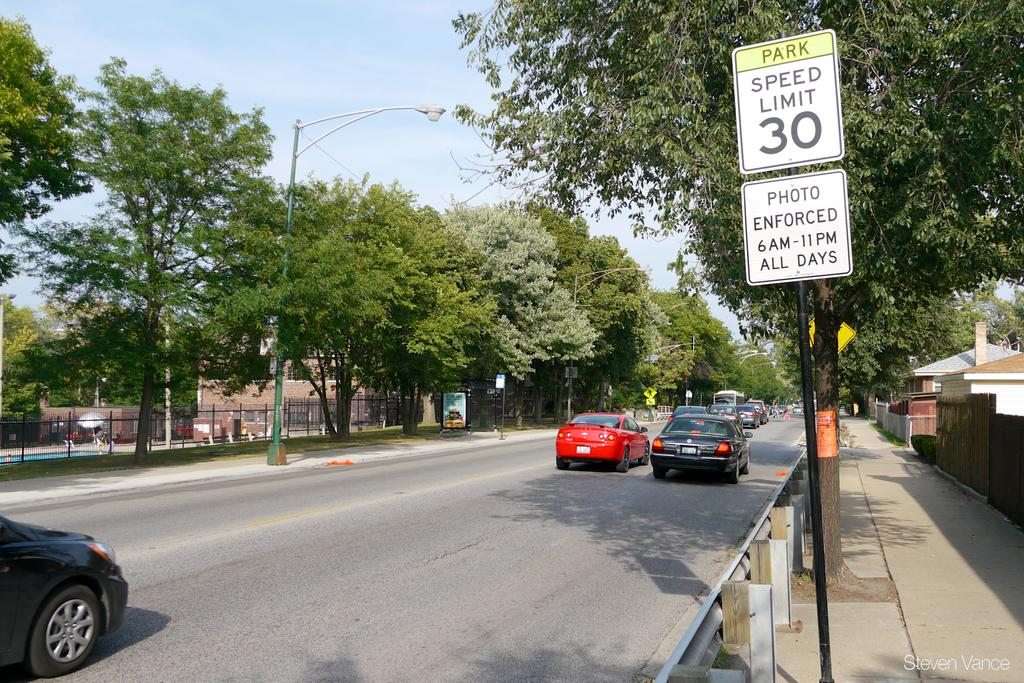<image>
Relay a brief, clear account of the picture shown. The street has a speed limit of 30 mph and is photo enforced on all days. 